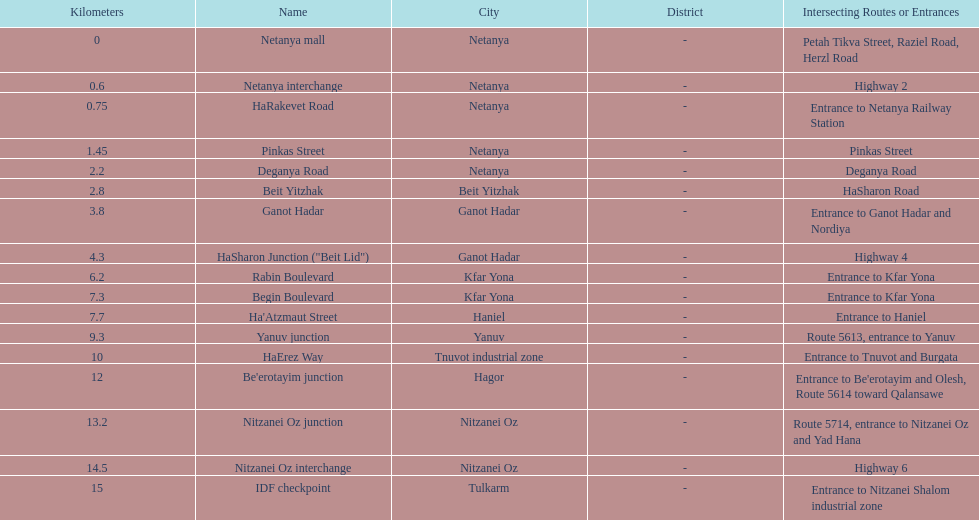How many locations in netanya are there? 5. 